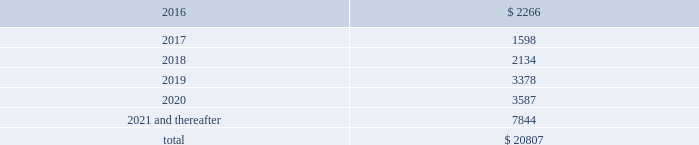Table of contents notes to consolidated financial statements of american airlines group inc .
Secured financings are collateralized by assets , primarily aircraft , engines , simulators , rotable aircraft parts , airport leasehold rights , route authorities and airport slots .
At december 31 , 2015 , the company was operating 35 aircraft under capital leases .
Leases can generally be renewed at rates based on fair market value at the end of the lease term for a number of additional years .
At december 31 , 2015 , the maturities of long-term debt and capital lease obligations are as follows ( in millions ) : .
( a ) 2013 credit facilities on june 27 , 2013 , american and aag entered into a credit and guaranty agreement ( as amended , restated , amended and restated or otherwise modified , the 2013 credit agreement ) with deutsche bank ag new york branch , as administrative agent , and certain lenders that originally provided for a $ 1.9 billion term loan facility scheduled to mature on june 27 , 2019 ( the 2013 term loan facility ) and a $ 1.0 billion revolving credit facility scheduled to mature on june 27 , 2018 ( the 2013 revolving facility ) .
The maturity of the term loan facility was subsequently extended to june 2020 and the revolving credit facility commitments were subsequently increased to $ 1.4 billion with an extended maturity date of october 10 , 2020 , all of which is further described below .
On may 21 , 2015 , american amended and restated the 2013 credit agreement pursuant to which it refinanced the 2013 term loan facility ( the $ 1.9 billion 2015 term loan facility and , together with the 2013 revolving facility , the 2013 credit facilities ) to extend the maturity date to june 2020 and reduce the libor margin from 3.00% ( 3.00 % ) to 2.75% ( 2.75 % ) .
In addition , american entered into certain amendments to reflect the ability for american to make future modifications to the collateral pledged , subject to certain restrictions .
The $ 1.9 billion 2015 term loan facility is repayable in annual installments , with the first installment in an amount equal to 1.25% ( 1.25 % ) of the principal amount commencing on june 27 , 2016 and installments thereafter , in an amount equal to 1.0% ( 1.0 % ) of the principal amount , with any unpaid balance due on the maturity date .
As of december 31 , 2015 , $ 1.9 billion of principal was outstanding under the $ 1.9 billion 2015 term loan facility .
Voluntary prepayments may be made by american at any time .
On october 10 , 2014 , american and aag amended the 2013 credit agreement to extend the maturity date of the 2013 revolving facility to october 10 , 2019 and increased the commitments thereunder to an aggregate principal amount of $ 1.4 billion while reducing the letter of credit commitments thereunder to $ 300 million .
On october 26 , 2015 , american , aag , us airways group and us airways amended the 2013 credit agreement to extend the maturity date of the 2013 revolving facility to october 10 , 2020 .
The 2013 revolving facility provides that american may from time to time borrow , repay and reborrow loans thereunder and have letters of credit issued thereunder .
As of december 31 , 2015 , there were no borrowings or letters of credit outstanding under the 2013 revolving facility .
The 2013 credit facilities bear interest at an index rate plus an applicable index margin or , at american 2019s option , libor ( subject to a floor of 0.75% ( 0.75 % ) , with respect to the $ 1.9 billion 2015 term loan facility ) plus a libor margin of 3.00% ( 3.00 % ) with respect to the 2013 revolving facility and 2.75% ( 2.75 % ) with respect to the $ 1.9 billion 2015 term loan facility ; provided that american 2019s corporate credit rating is ba3 or higher from moody 2019s and bb- or higher from s&p , the applicable libor margin would be 2.50% ( 2.50 % ) for the $ 1.9 billion 2015 term loan .
What is the amount of the first installment of the 19 billion 2015 term loan facility payable on june 27 , 2016 in billions? 
Rationale: to obtain the amount of the fisrt installment multiply the loan amount by the amount of the % stated for the first installment
Computations: (1.9 * 1.25%)
Answer: 0.02375. Table of contents notes to consolidated financial statements of american airlines group inc .
Secured financings are collateralized by assets , primarily aircraft , engines , simulators , rotable aircraft parts , airport leasehold rights , route authorities and airport slots .
At december 31 , 2015 , the company was operating 35 aircraft under capital leases .
Leases can generally be renewed at rates based on fair market value at the end of the lease term for a number of additional years .
At december 31 , 2015 , the maturities of long-term debt and capital lease obligations are as follows ( in millions ) : .
( a ) 2013 credit facilities on june 27 , 2013 , american and aag entered into a credit and guaranty agreement ( as amended , restated , amended and restated or otherwise modified , the 2013 credit agreement ) with deutsche bank ag new york branch , as administrative agent , and certain lenders that originally provided for a $ 1.9 billion term loan facility scheduled to mature on june 27 , 2019 ( the 2013 term loan facility ) and a $ 1.0 billion revolving credit facility scheduled to mature on june 27 , 2018 ( the 2013 revolving facility ) .
The maturity of the term loan facility was subsequently extended to june 2020 and the revolving credit facility commitments were subsequently increased to $ 1.4 billion with an extended maturity date of october 10 , 2020 , all of which is further described below .
On may 21 , 2015 , american amended and restated the 2013 credit agreement pursuant to which it refinanced the 2013 term loan facility ( the $ 1.9 billion 2015 term loan facility and , together with the 2013 revolving facility , the 2013 credit facilities ) to extend the maturity date to june 2020 and reduce the libor margin from 3.00% ( 3.00 % ) to 2.75% ( 2.75 % ) .
In addition , american entered into certain amendments to reflect the ability for american to make future modifications to the collateral pledged , subject to certain restrictions .
The $ 1.9 billion 2015 term loan facility is repayable in annual installments , with the first installment in an amount equal to 1.25% ( 1.25 % ) of the principal amount commencing on june 27 , 2016 and installments thereafter , in an amount equal to 1.0% ( 1.0 % ) of the principal amount , with any unpaid balance due on the maturity date .
As of december 31 , 2015 , $ 1.9 billion of principal was outstanding under the $ 1.9 billion 2015 term loan facility .
Voluntary prepayments may be made by american at any time .
On october 10 , 2014 , american and aag amended the 2013 credit agreement to extend the maturity date of the 2013 revolving facility to october 10 , 2019 and increased the commitments thereunder to an aggregate principal amount of $ 1.4 billion while reducing the letter of credit commitments thereunder to $ 300 million .
On october 26 , 2015 , american , aag , us airways group and us airways amended the 2013 credit agreement to extend the maturity date of the 2013 revolving facility to october 10 , 2020 .
The 2013 revolving facility provides that american may from time to time borrow , repay and reborrow loans thereunder and have letters of credit issued thereunder .
As of december 31 , 2015 , there were no borrowings or letters of credit outstanding under the 2013 revolving facility .
The 2013 credit facilities bear interest at an index rate plus an applicable index margin or , at american 2019s option , libor ( subject to a floor of 0.75% ( 0.75 % ) , with respect to the $ 1.9 billion 2015 term loan facility ) plus a libor margin of 3.00% ( 3.00 % ) with respect to the 2013 revolving facility and 2.75% ( 2.75 % ) with respect to the $ 1.9 billion 2015 term loan facility ; provided that american 2019s corporate credit rating is ba3 or higher from moody 2019s and bb- or higher from s&p , the applicable libor margin would be 2.50% ( 2.50 % ) for the $ 1.9 billion 2015 term loan .
What percentage of total maturities of long-term debt and capital lease obligations are payable in 2019? 
Computations: (3378 / 20807)
Answer: 0.16235. Table of contents notes to consolidated financial statements of american airlines group inc .
Secured financings are collateralized by assets , primarily aircraft , engines , simulators , rotable aircraft parts , airport leasehold rights , route authorities and airport slots .
At december 31 , 2015 , the company was operating 35 aircraft under capital leases .
Leases can generally be renewed at rates based on fair market value at the end of the lease term for a number of additional years .
At december 31 , 2015 , the maturities of long-term debt and capital lease obligations are as follows ( in millions ) : .
( a ) 2013 credit facilities on june 27 , 2013 , american and aag entered into a credit and guaranty agreement ( as amended , restated , amended and restated or otherwise modified , the 2013 credit agreement ) with deutsche bank ag new york branch , as administrative agent , and certain lenders that originally provided for a $ 1.9 billion term loan facility scheduled to mature on june 27 , 2019 ( the 2013 term loan facility ) and a $ 1.0 billion revolving credit facility scheduled to mature on june 27 , 2018 ( the 2013 revolving facility ) .
The maturity of the term loan facility was subsequently extended to june 2020 and the revolving credit facility commitments were subsequently increased to $ 1.4 billion with an extended maturity date of october 10 , 2020 , all of which is further described below .
On may 21 , 2015 , american amended and restated the 2013 credit agreement pursuant to which it refinanced the 2013 term loan facility ( the $ 1.9 billion 2015 term loan facility and , together with the 2013 revolving facility , the 2013 credit facilities ) to extend the maturity date to june 2020 and reduce the libor margin from 3.00% ( 3.00 % ) to 2.75% ( 2.75 % ) .
In addition , american entered into certain amendments to reflect the ability for american to make future modifications to the collateral pledged , subject to certain restrictions .
The $ 1.9 billion 2015 term loan facility is repayable in annual installments , with the first installment in an amount equal to 1.25% ( 1.25 % ) of the principal amount commencing on june 27 , 2016 and installments thereafter , in an amount equal to 1.0% ( 1.0 % ) of the principal amount , with any unpaid balance due on the maturity date .
As of december 31 , 2015 , $ 1.9 billion of principal was outstanding under the $ 1.9 billion 2015 term loan facility .
Voluntary prepayments may be made by american at any time .
On october 10 , 2014 , american and aag amended the 2013 credit agreement to extend the maturity date of the 2013 revolving facility to october 10 , 2019 and increased the commitments thereunder to an aggregate principal amount of $ 1.4 billion while reducing the letter of credit commitments thereunder to $ 300 million .
On october 26 , 2015 , american , aag , us airways group and us airways amended the 2013 credit agreement to extend the maturity date of the 2013 revolving facility to october 10 , 2020 .
The 2013 revolving facility provides that american may from time to time borrow , repay and reborrow loans thereunder and have letters of credit issued thereunder .
As of december 31 , 2015 , there were no borrowings or letters of credit outstanding under the 2013 revolving facility .
The 2013 credit facilities bear interest at an index rate plus an applicable index margin or , at american 2019s option , libor ( subject to a floor of 0.75% ( 0.75 % ) , with respect to the $ 1.9 billion 2015 term loan facility ) plus a libor margin of 3.00% ( 3.00 % ) with respect to the 2013 revolving facility and 2.75% ( 2.75 % ) with respect to the $ 1.9 billion 2015 term loan facility ; provided that american 2019s corporate credit rating is ba3 or higher from moody 2019s and bb- or higher from s&p , the applicable libor margin would be 2.50% ( 2.50 % ) for the $ 1.9 billion 2015 term loan .
What is the percent of the lease expenses after 2021 as a part of the total amount? 
Rationale: to find the percent , divide the amount by the total
Computations: (7844 / 20807)
Answer: 0.37699. 